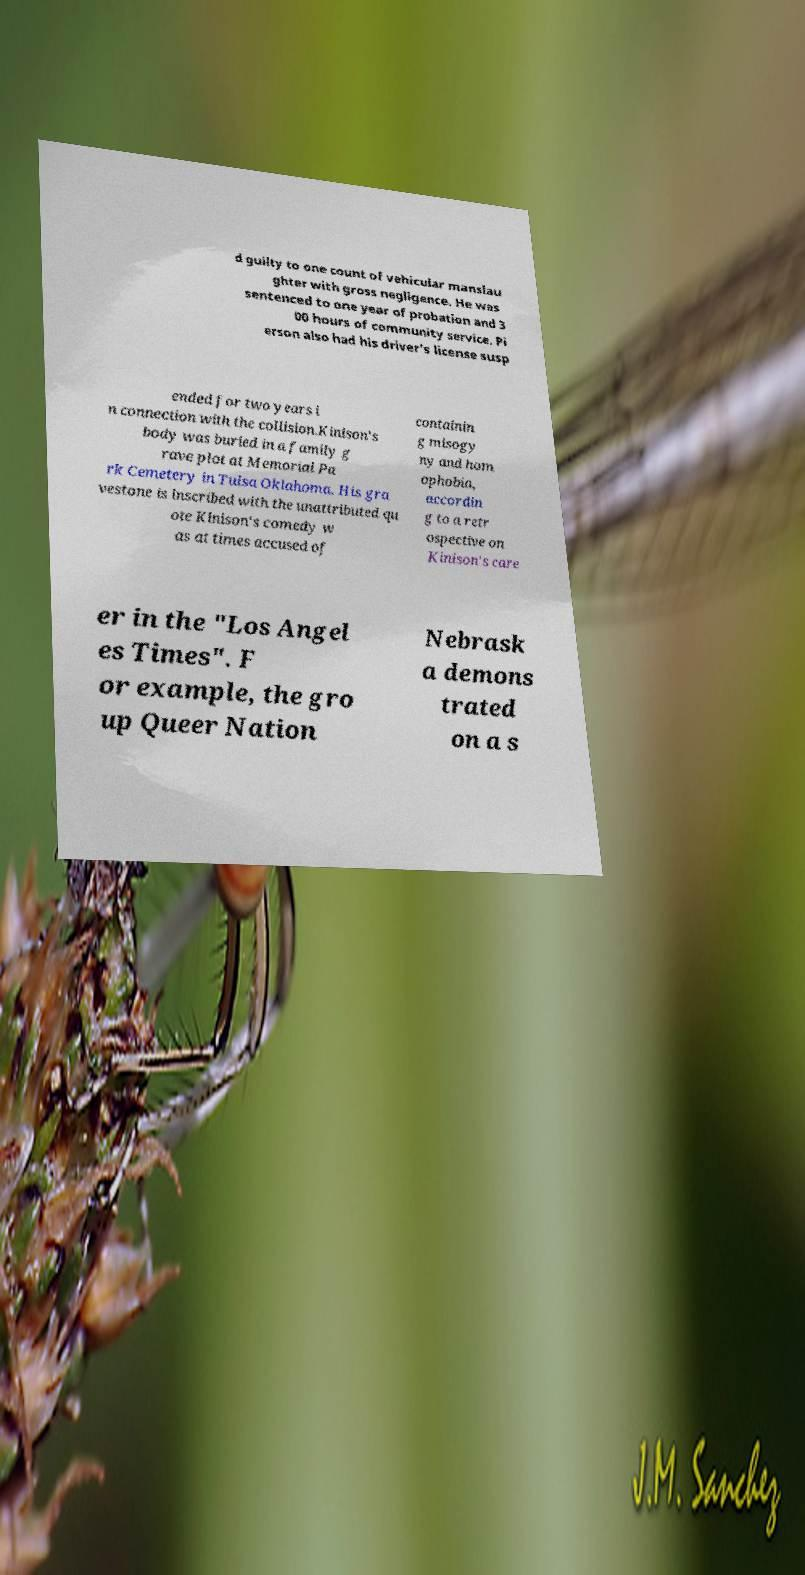I need the written content from this picture converted into text. Can you do that? d guilty to one count of vehicular manslau ghter with gross negligence. He was sentenced to one year of probation and 3 00 hours of community service. Pi erson also had his driver's license susp ended for two years i n connection with the collision.Kinison's body was buried in a family g rave plot at Memorial Pa rk Cemetery in Tulsa Oklahoma. His gra vestone is inscribed with the unattributed qu ote Kinison's comedy w as at times accused of containin g misogy ny and hom ophobia, accordin g to a retr ospective on Kinison's care er in the "Los Angel es Times". F or example, the gro up Queer Nation Nebrask a demons trated on a s 